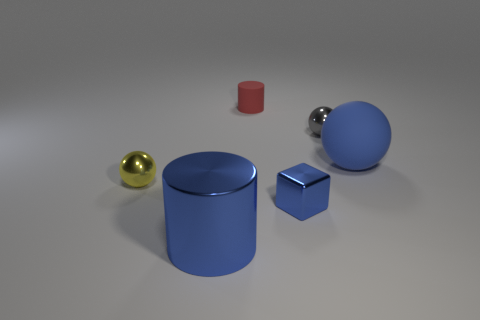How many spheres are tiny red rubber objects or blue metal things?
Keep it short and to the point. 0. What number of shiny spheres have the same size as the gray metal object?
Ensure brevity in your answer.  1. What number of cylinders are in front of the blue shiny object that is to the left of the red rubber cylinder?
Your answer should be compact. 0. What size is the metallic thing that is to the left of the small shiny block and behind the big shiny object?
Offer a terse response. Small. Are there more blue matte cylinders than small gray shiny things?
Make the answer very short. No. Is there a rubber cylinder of the same color as the metallic cylinder?
Keep it short and to the point. No. Do the cylinder that is behind the blue ball and the tiny blue shiny thing have the same size?
Your answer should be compact. Yes. Are there fewer small yellow objects than small red metal cylinders?
Make the answer very short. No. Is there a blue block made of the same material as the yellow ball?
Offer a very short reply. Yes. There is a matte object that is on the right side of the gray shiny thing; what is its shape?
Offer a terse response. Sphere. 